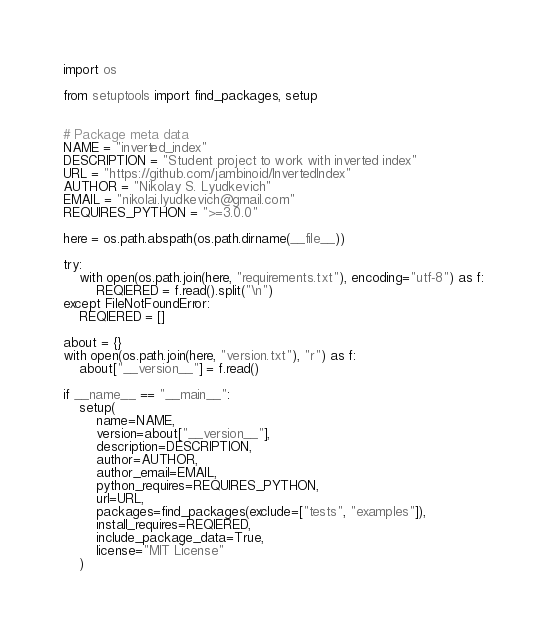<code> <loc_0><loc_0><loc_500><loc_500><_Python_>import os

from setuptools import find_packages, setup


# Package meta data
NAME = "inverted_index"
DESCRIPTION = "Student project to work with inverted index"
URL = "https://github.com/jambinoid/InvertedIndex"
AUTHOR = "Nikolay S. Lyudkevich"
EMAIL = "nikolai.lyudkevich@gmail.com"
REQUIRES_PYTHON = ">=3.0.0"

here = os.path.abspath(os.path.dirname(__file__))

try:
    with open(os.path.join(here, "requirements.txt"), encoding="utf-8") as f:
        REQIERED = f.read().split("\n")
except FileNotFoundError:
    REQIERED = []

about = {}
with open(os.path.join(here, "version.txt"), "r") as f:
    about["__version__"] = f.read()

if __name__ == "__main__":
    setup(
        name=NAME,
        version=about["__version__"],
        description=DESCRIPTION,
        author=AUTHOR,
        author_email=EMAIL,
        python_requires=REQUIRES_PYTHON,
        url=URL,
        packages=find_packages(exclude=["tests", "examples"]),
        install_requires=REQIERED,
        include_package_data=True,
        license="MIT License"
    )</code> 